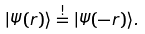<formula> <loc_0><loc_0><loc_500><loc_500>| \Psi ( r ) \rangle \stackrel { ! } = | \Psi ( - r ) \rangle .</formula> 